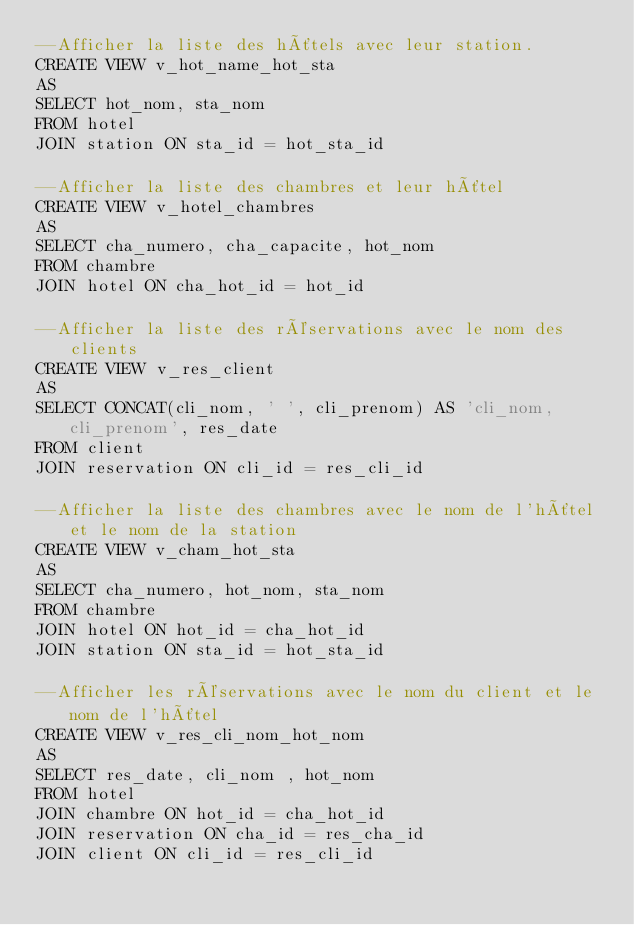Convert code to text. <code><loc_0><loc_0><loc_500><loc_500><_SQL_>--Afficher la liste des hôtels avec leur station.
CREATE VIEW v_hot_name_hot_sta
AS
SELECT hot_nom, sta_nom
FROM hotel
JOIN station ON sta_id = hot_sta_id

--Afficher la liste des chambres et leur hôtel
CREATE VIEW v_hotel_chambres
AS
SELECT cha_numero, cha_capacite, hot_nom
FROM chambre
JOIN hotel ON cha_hot_id = hot_id

--Afficher la liste des réservations avec le nom des clients
CREATE VIEW v_res_client
AS
SELECT CONCAT(cli_nom, ' ', cli_prenom) AS 'cli_nom, cli_prenom', res_date 
FROM client
JOIN reservation ON cli_id = res_cli_id

--Afficher la liste des chambres avec le nom de l'hôtel et le nom de la station
CREATE VIEW v_cham_hot_sta
AS
SELECT cha_numero, hot_nom, sta_nom
FROM chambre
JOIN hotel ON hot_id = cha_hot_id
JOIN station ON sta_id = hot_sta_id

--Afficher les réservations avec le nom du client et le nom de l'hôtel
CREATE VIEW v_res_cli_nom_hot_nom
AS
SELECT res_date, cli_nom , hot_nom
FROM hotel
JOIN chambre ON hot_id = cha_hot_id
JOIN reservation ON cha_id = res_cha_id
JOIN client ON cli_id = res_cli_id</code> 